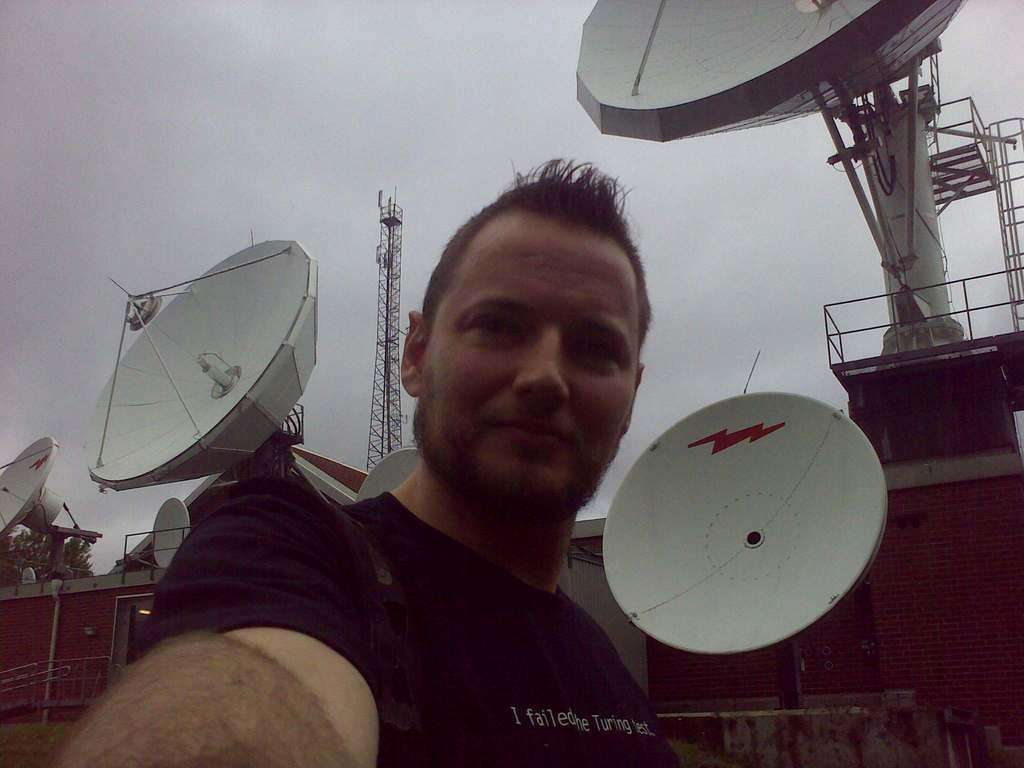What is the main subject of the image? There is a person in the image. What can be seen in the background of the image? There are antennas, buildings, towers, trees, and the sky visible in the background of the image. What type of silk is draped over the person's shoulders in the image? There is no silk present in the image; the person is not wearing any fabric or clothing that resembles silk. 